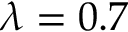<formula> <loc_0><loc_0><loc_500><loc_500>\lambda = 0 . 7</formula> 